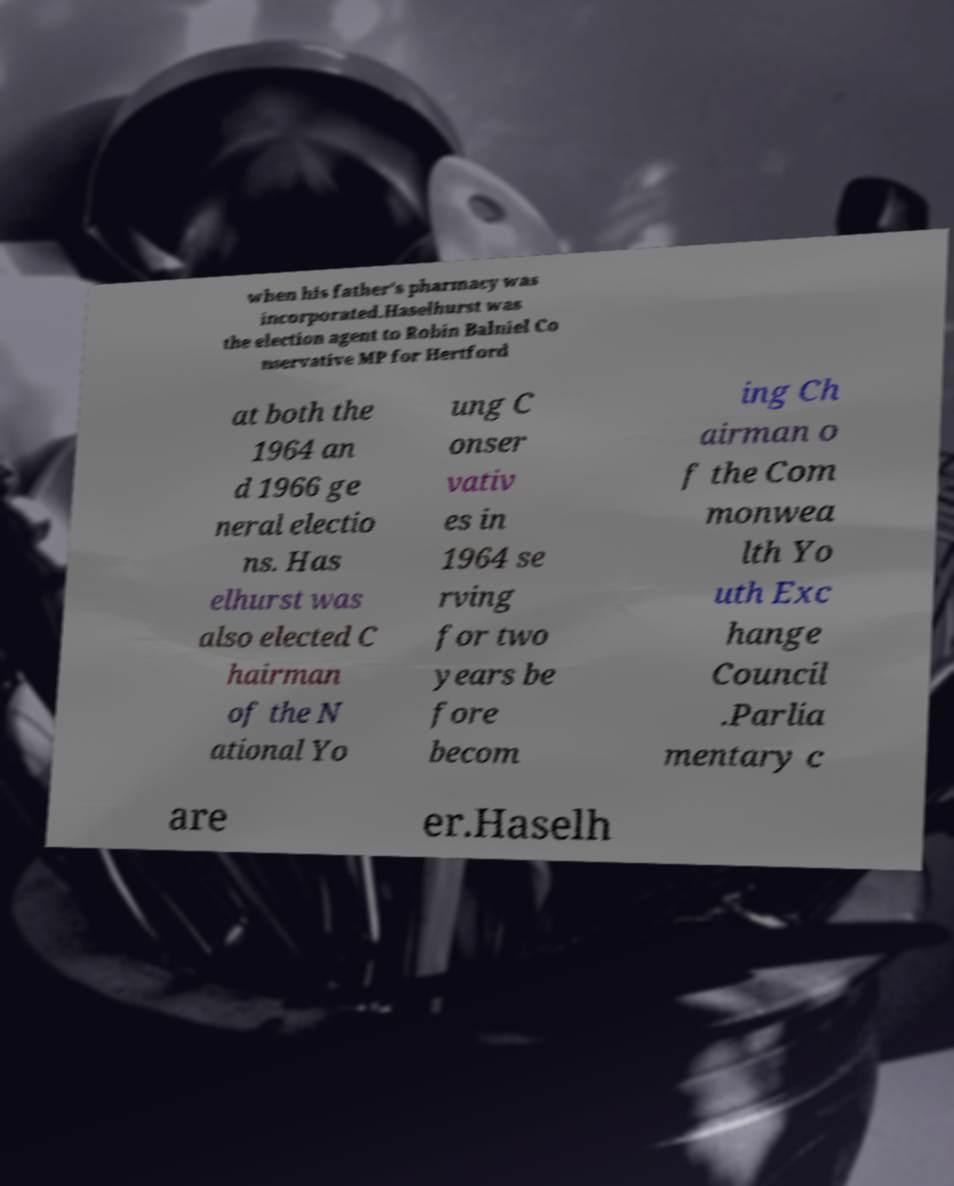Please read and relay the text visible in this image. What does it say? when his father's pharmacy was incorporated.Haselhurst was the election agent to Robin Balniel Co nservative MP for Hertford at both the 1964 an d 1966 ge neral electio ns. Has elhurst was also elected C hairman of the N ational Yo ung C onser vativ es in 1964 se rving for two years be fore becom ing Ch airman o f the Com monwea lth Yo uth Exc hange Council .Parlia mentary c are er.Haselh 